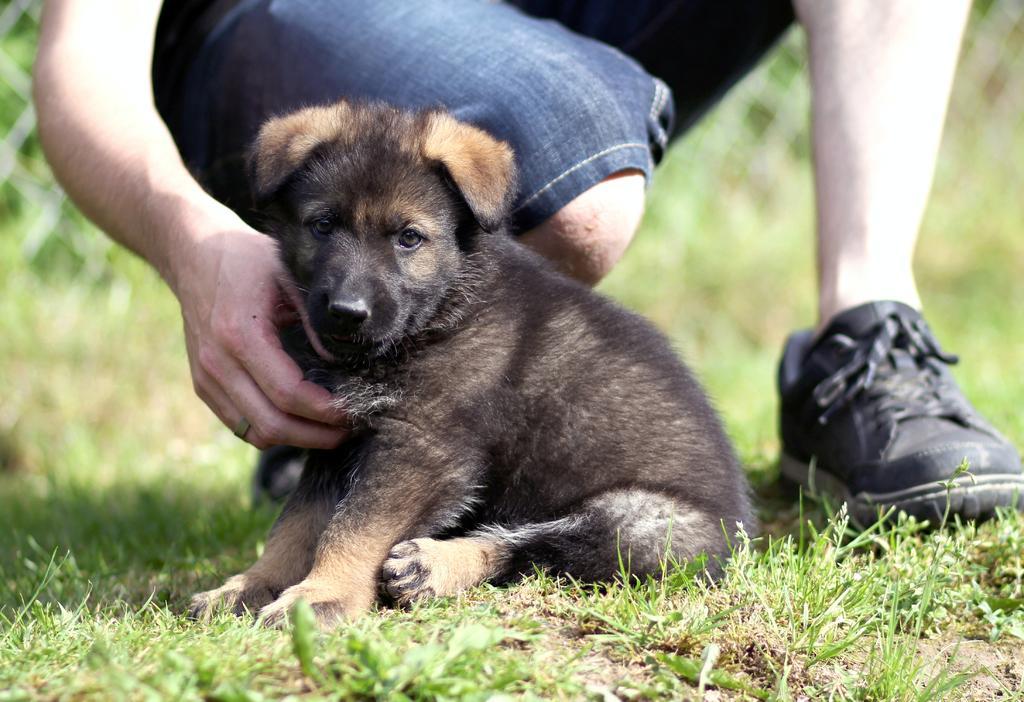How would you summarize this image in a sentence or two? In this picture we can see a puppy is sitting on the grass path and a person is in squat position. Behind the person there is a blurred background. 